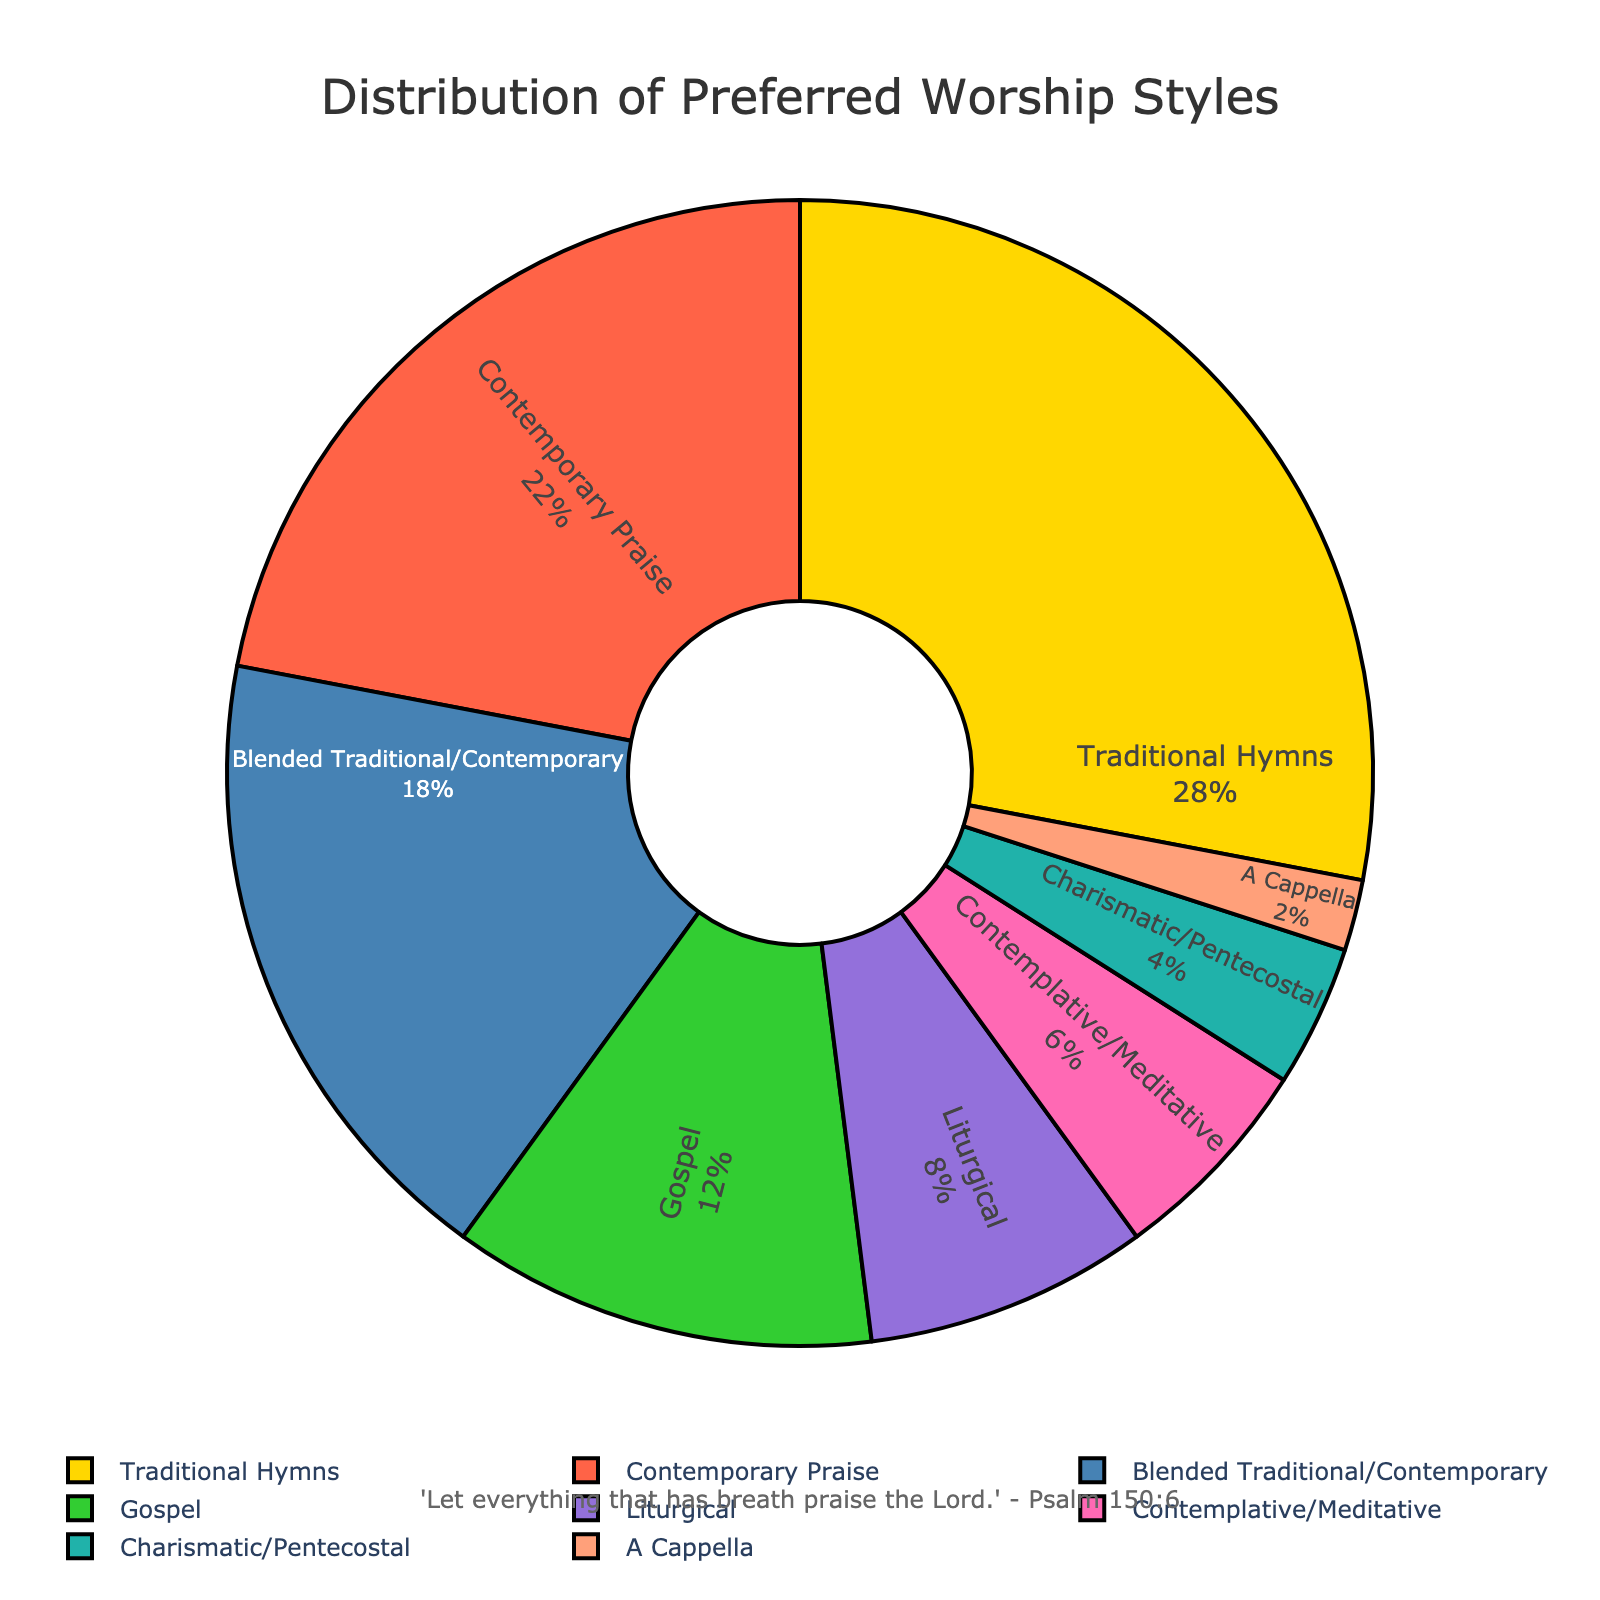Which worship style is preferred by the largest percentage of congregants? According to the pie chart, the slice representing "Traditional Hymns" is the largest in size and has the highest percentage value indicated inside the slice.
Answer: Traditional Hymns What is the combined percentage of congregants who prefer Contemporary Praise and Gospel styles? From the figure, Contemporary Praise has 22% and Gospel has 12%. Adding them together: 22% + 12% = 34%.
Answer: 34% How does the percentage of those who prefer Blended Traditional/Contemporary compare to those who prefer Liturgical? The pie chart shows that Blended Traditional/Contemporary has 18% and Liturgical has 8%. Therefore, 18% is greater than 8%.
Answer: Blended Traditional/Contemporary is greater Which worship style has the least preference among the congregation members? By observing the smallest slice in the pie chart, it is seen that "A Cappella" has the smallest percentage, which is indicated as 2%.
Answer: A Cappella What is the total percentage of congregants preferring worship styles that are less than 10% each? The styles with less than 10% each are Liturgical (8%), Contemplative/Meditative (6%), Charismatic/Pentecostal (4%), and A Cappella (2%). Summing these: 8% + 6% + 4% + 2% = 20%.
Answer: 20% Compare the preference between Traditional Hymns and Contemporary Praise. What is the percentage difference between these two styles? Traditional Hymns have 28% and Contemporary Praise has 22%. The difference is calculated as 28% - 22% = 6%.
Answer: 6% If you combine the percentages of Blended Traditional/Contemporary and Charismatic/Pentecostal styles, how does this value compare to the percentage for Traditional Hymns? Blended Traditional/Contemporary is 18% and Charismatic/Pentecostal is 4%. Adding them: 18% + 4% = 22%. Comparing this with Traditional Hymns' 28%, 22% is less than 28%.
Answer: 22% is less What is the approximate percentage of congregants who prefer styles that are not either Traditional Hymns or Contemporary Praise? Subtracting the percentages of Traditional Hymns (28%) and Contemporary Praise (22%) from 100%: 100% - (28% + 22%) = 50%.
Answer: 50% 